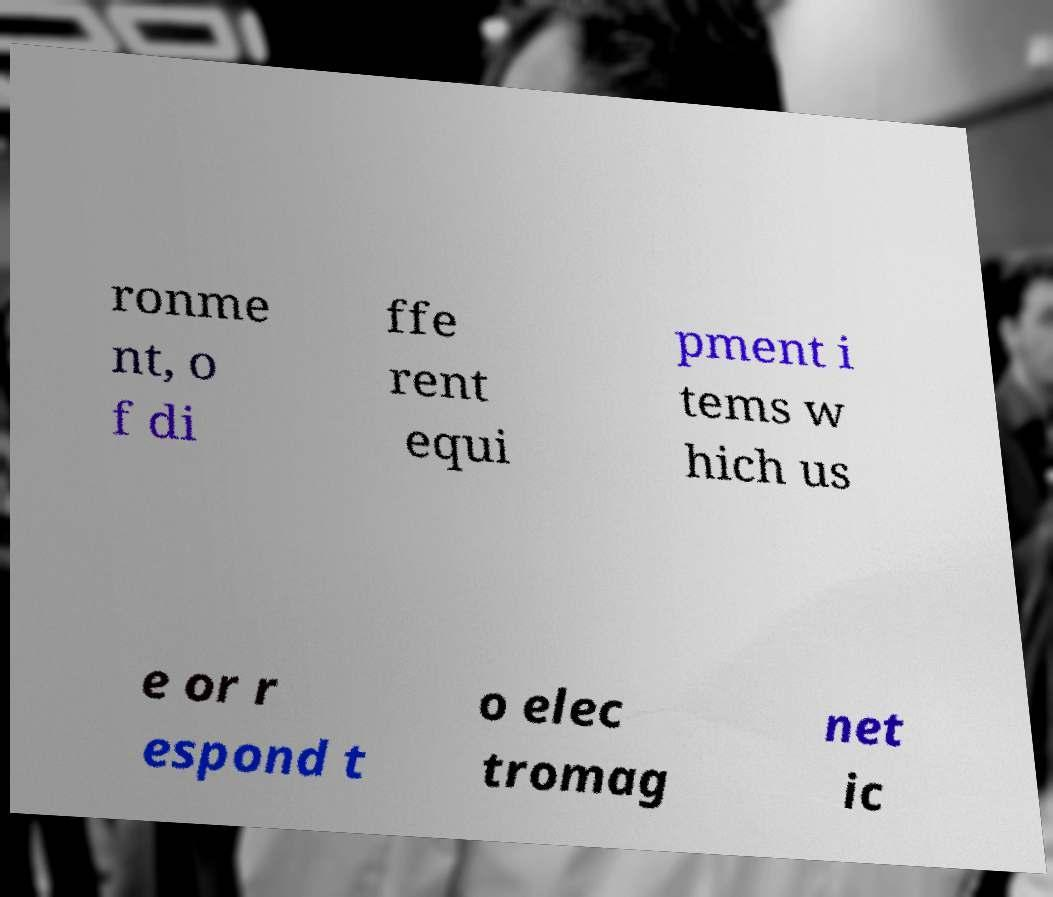Can you read and provide the text displayed in the image?This photo seems to have some interesting text. Can you extract and type it out for me? ronme nt, o f di ffe rent equi pment i tems w hich us e or r espond t o elec tromag net ic 